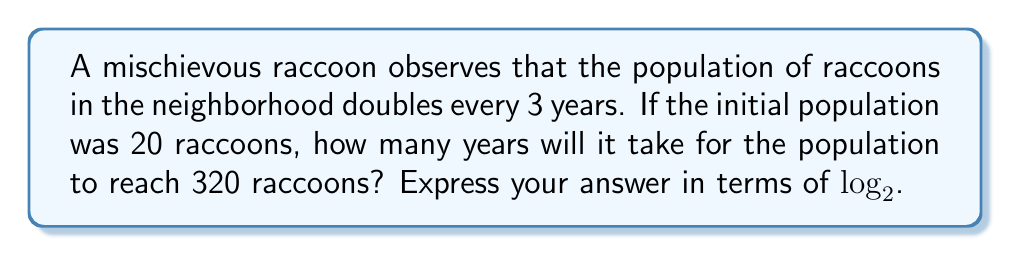Provide a solution to this math problem. Let's approach this step-by-step:

1) First, we need to set up our exponential growth model. The general form is:

   $P(t) = P_0 \cdot b^t$

   Where $P(t)$ is the population at time $t$, $P_0$ is the initial population, and $b$ is the growth factor per unit time.

2) We know that:
   - $P_0 = 20$ (initial population)
   - The population doubles every 3 years, so $b = 2^{\frac{1}{3}}$

3) Our model becomes:

   $P(t) = 20 \cdot (2^{\frac{1}{3}})^t = 20 \cdot 2^{\frac{t}{3}}$

4) We want to find $t$ when $P(t) = 320$. So we set up the equation:

   $320 = 20 \cdot 2^{\frac{t}{3}}$

5) Divide both sides by 20:

   $16 = 2^{\frac{t}{3}}$

6) Now we can apply $\log_2$ to both sides:

   $\log_2(16) = \log_2(2^{\frac{t}{3}})$

7) Simplify the left side and apply the logarithm property on the right:

   $4 = \frac{t}{3}$

8) Multiply both sides by 3:

   $12 = t$

9) Therefore, it will take 12 years for the population to reach 320 raccoons.

10) To express this in terms of $\log_2$ as requested, we can rewrite the solution as:

    $t = 3 \cdot \log_2(16) = 3 \cdot 4 = 12$
Answer: $t = 3 \cdot \log_2(16)$ years 